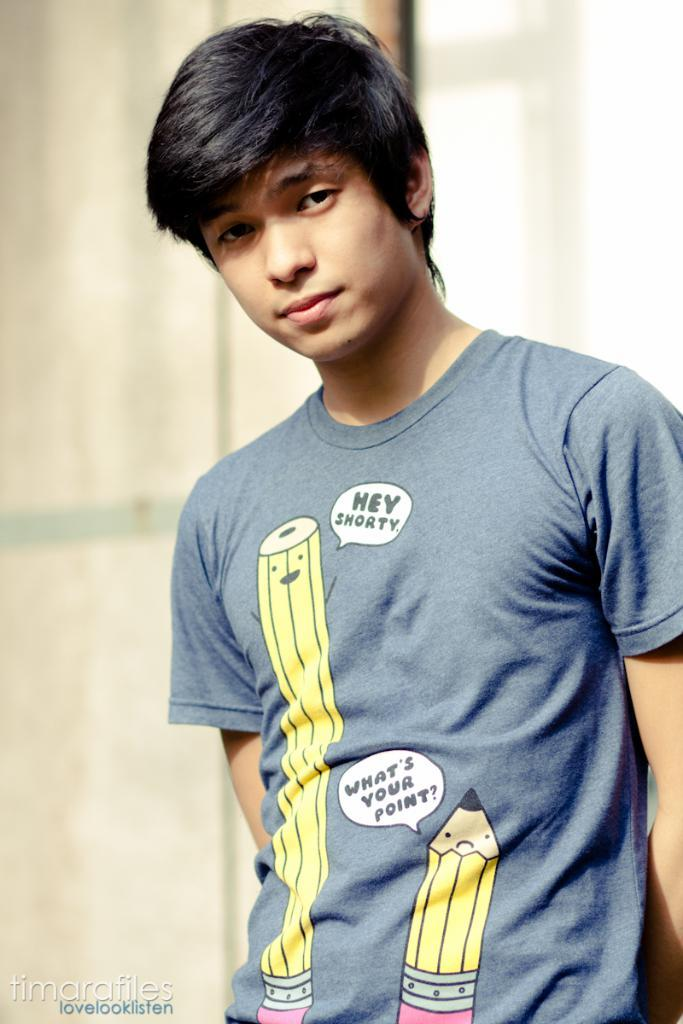<image>
Relay a brief, clear account of the picture shown. A boy is wearing a blue shirt with pictures of two pencils and one is saying Hey Shorty to the shorter one. 